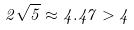<formula> <loc_0><loc_0><loc_500><loc_500>2 \sqrt { 5 } \approx 4 . 4 7 > 4</formula> 